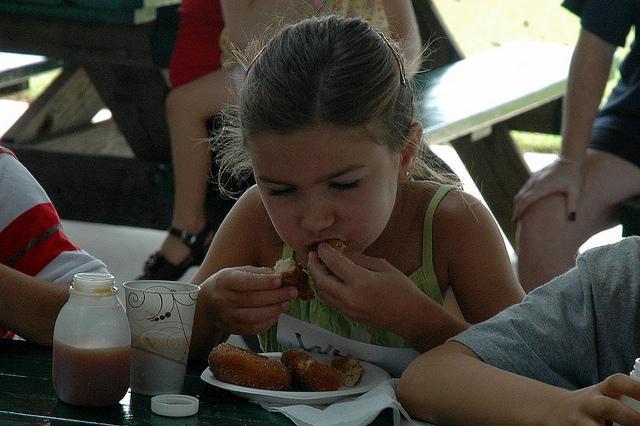How many donuts are there?
Give a very brief answer. 2. How many benches are there?
Give a very brief answer. 2. How many people are there?
Give a very brief answer. 5. How many slices of orange are there?
Give a very brief answer. 0. 